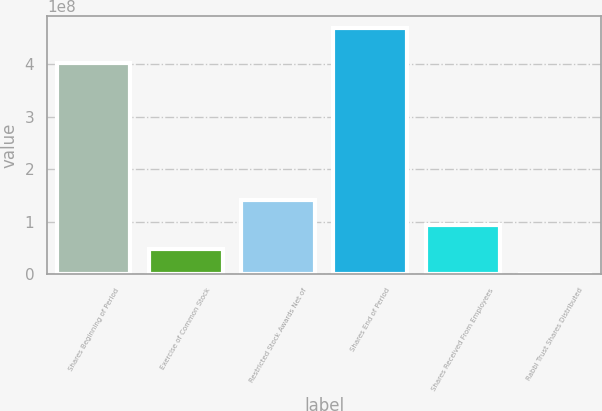<chart> <loc_0><loc_0><loc_500><loc_500><bar_chart><fcel>Shares Beginning of Period<fcel>Exercise of Common Stock<fcel>Restricted Stock Awards Net of<fcel>Shares End of Period<fcel>Shares Received From Employees<fcel>Rabbi Trust Shares Distributed<nl><fcel>4.02329e+08<fcel>4.71528e+07<fcel>1.41056e+08<fcel>4.69719e+08<fcel>9.41045e+07<fcel>201009<nl></chart> 